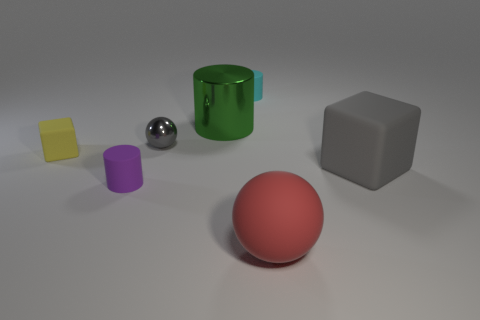Subtract all matte cylinders. How many cylinders are left? 1 Subtract all blue cylinders. How many green blocks are left? 0 Add 3 metallic spheres. How many metallic spheres exist? 4 Add 2 large metal cylinders. How many objects exist? 9 Subtract all green cylinders. How many cylinders are left? 2 Subtract 1 gray spheres. How many objects are left? 6 Subtract all cubes. How many objects are left? 5 Subtract 1 blocks. How many blocks are left? 1 Subtract all gray spheres. Subtract all green cylinders. How many spheres are left? 1 Subtract all matte blocks. Subtract all small purple cylinders. How many objects are left? 4 